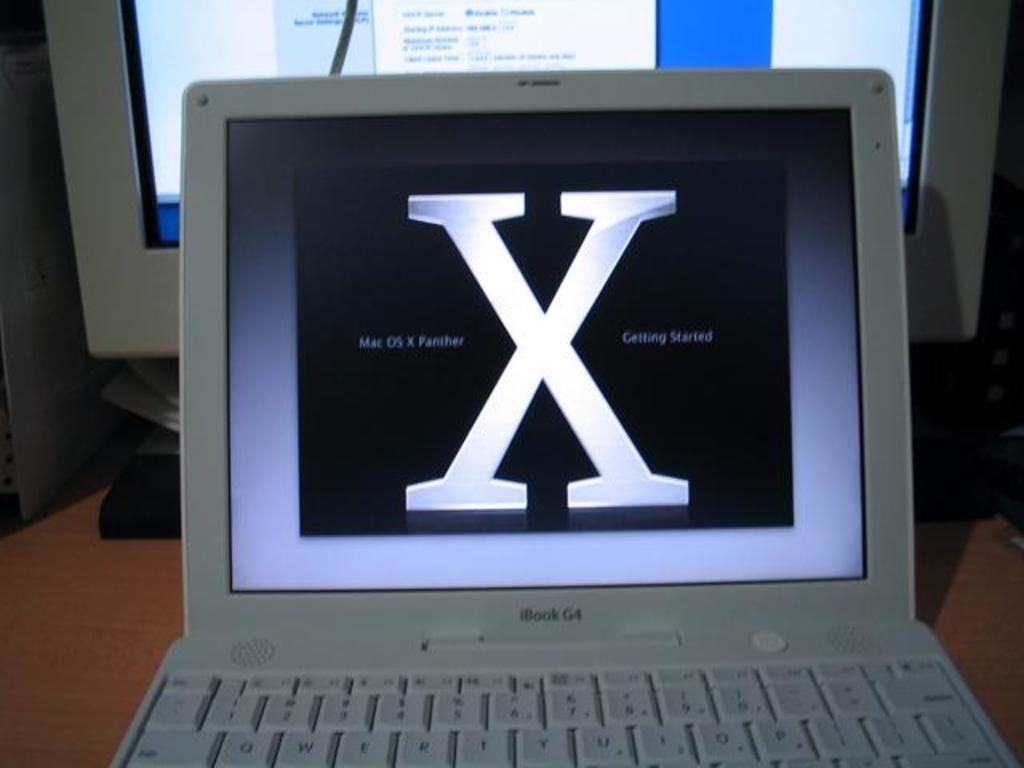Provide a one-sentence caption for the provided image. ibook g4 with mac os x panther on black screen. 